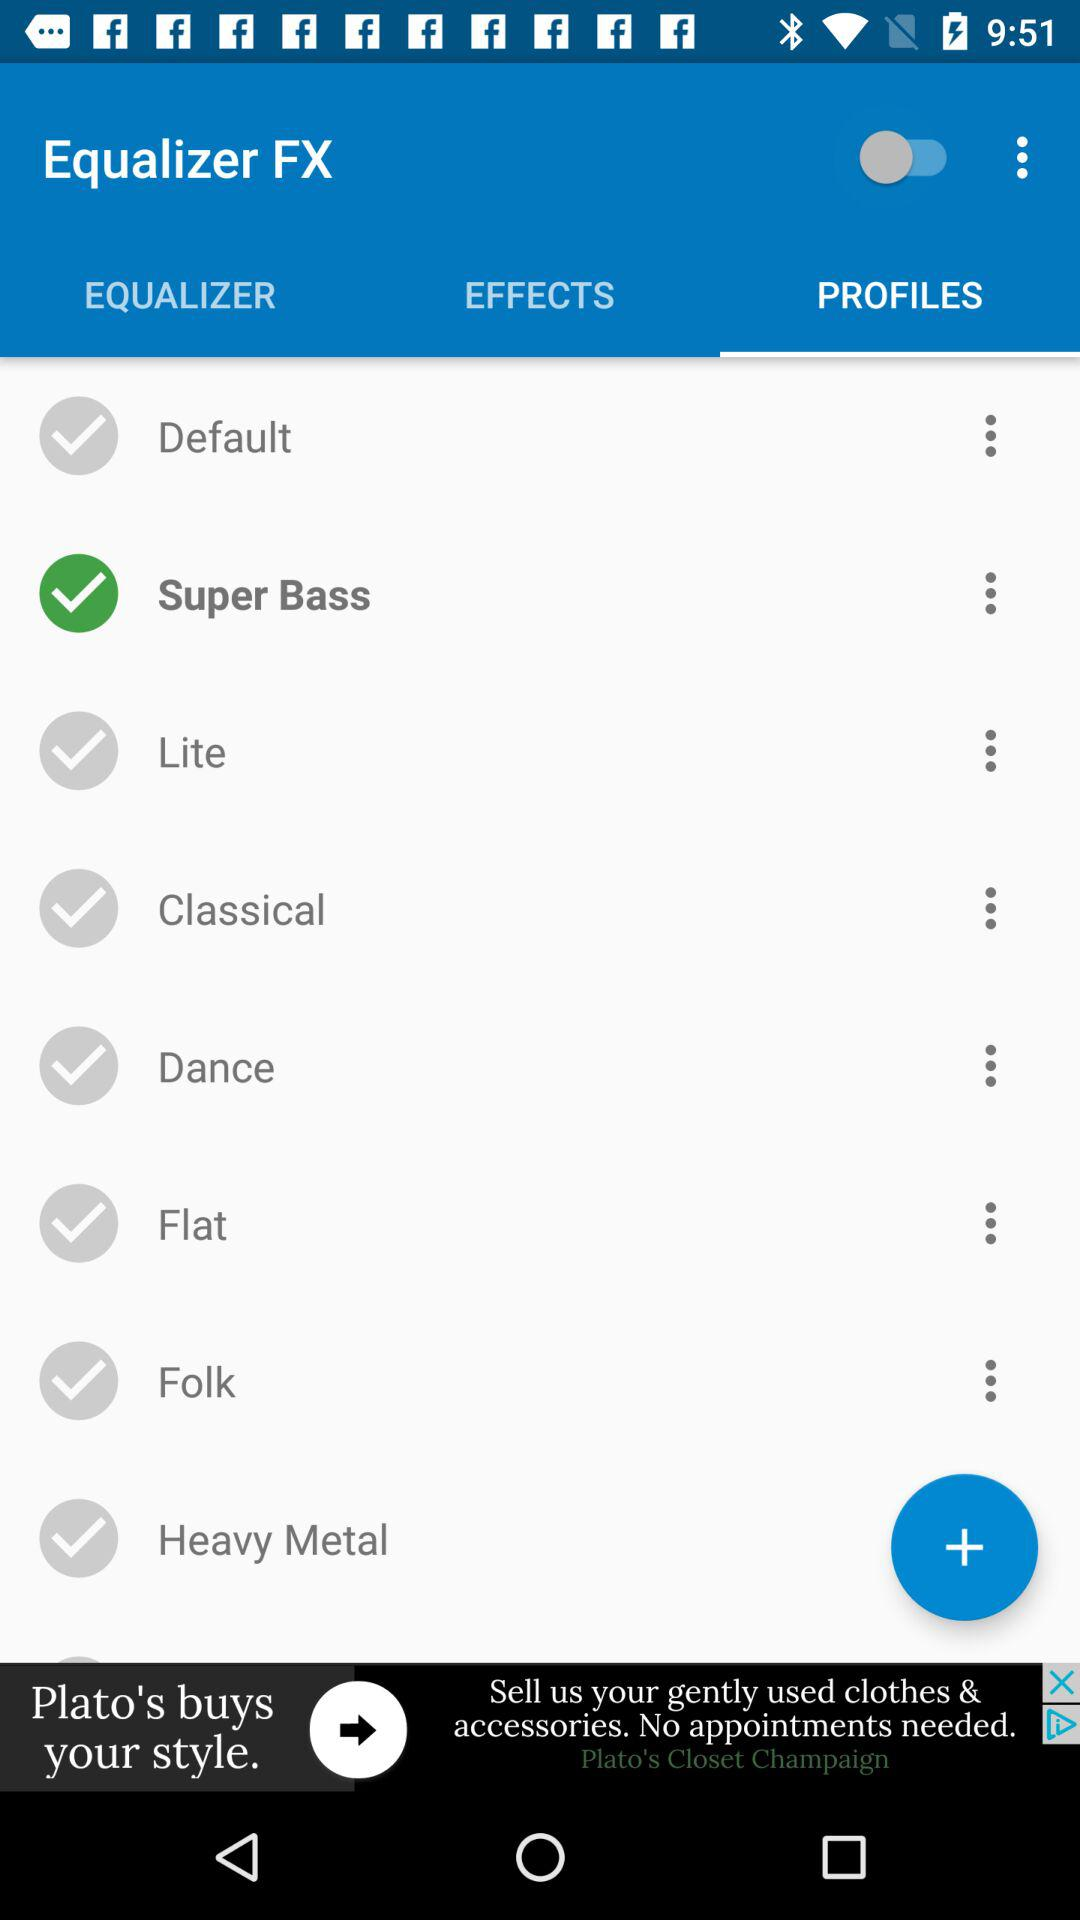Which tab is selected? The selected tab is "PROFILES". 